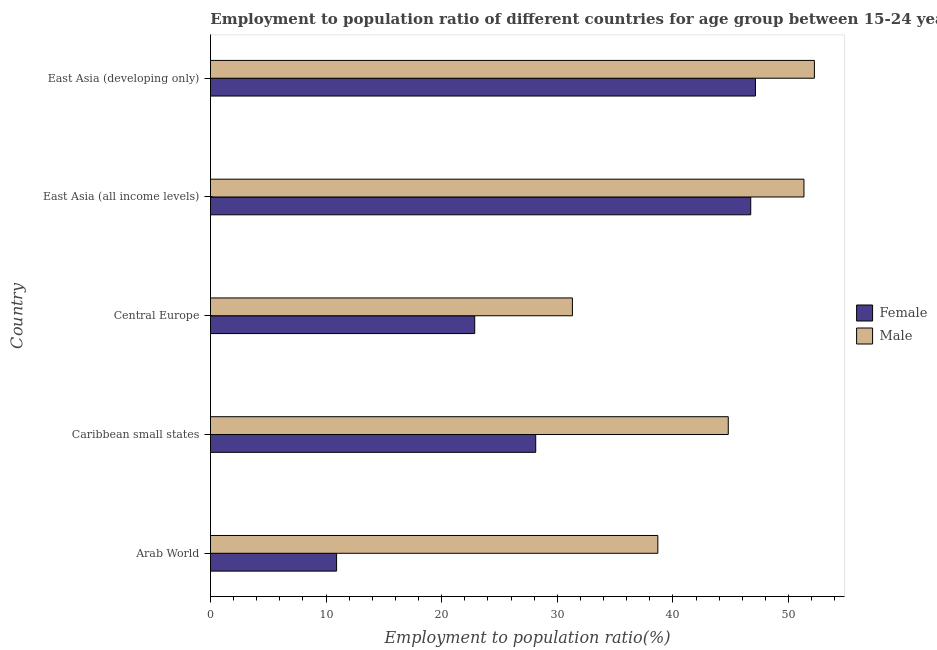How many different coloured bars are there?
Offer a terse response. 2. How many groups of bars are there?
Provide a short and direct response. 5. Are the number of bars on each tick of the Y-axis equal?
Give a very brief answer. Yes. How many bars are there on the 4th tick from the bottom?
Provide a short and direct response. 2. What is the label of the 2nd group of bars from the top?
Keep it short and to the point. East Asia (all income levels). In how many cases, is the number of bars for a given country not equal to the number of legend labels?
Keep it short and to the point. 0. What is the employment to population ratio(male) in Central Europe?
Ensure brevity in your answer.  31.31. Across all countries, what is the maximum employment to population ratio(male)?
Provide a short and direct response. 52.23. Across all countries, what is the minimum employment to population ratio(male)?
Offer a very short reply. 31.31. In which country was the employment to population ratio(female) maximum?
Offer a very short reply. East Asia (developing only). In which country was the employment to population ratio(female) minimum?
Offer a terse response. Arab World. What is the total employment to population ratio(female) in the graph?
Your answer should be compact. 155.76. What is the difference between the employment to population ratio(male) in Arab World and that in East Asia (developing only)?
Give a very brief answer. -13.54. What is the difference between the employment to population ratio(female) in East Asia (developing only) and the employment to population ratio(male) in Arab World?
Offer a very short reply. 8.44. What is the average employment to population ratio(male) per country?
Keep it short and to the point. 43.67. What is the difference between the employment to population ratio(male) and employment to population ratio(female) in Arab World?
Offer a terse response. 27.79. What is the ratio of the employment to population ratio(male) in Caribbean small states to that in Central Europe?
Provide a short and direct response. 1.43. Is the difference between the employment to population ratio(male) in Arab World and Caribbean small states greater than the difference between the employment to population ratio(female) in Arab World and Caribbean small states?
Keep it short and to the point. Yes. What is the difference between the highest and the second highest employment to population ratio(female)?
Your response must be concise. 0.41. What is the difference between the highest and the lowest employment to population ratio(female)?
Your response must be concise. 36.23. What does the 1st bar from the top in East Asia (all income levels) represents?
Your answer should be very brief. Male. Are all the bars in the graph horizontal?
Offer a very short reply. Yes. Does the graph contain any zero values?
Ensure brevity in your answer.  No. Does the graph contain grids?
Give a very brief answer. No. Where does the legend appear in the graph?
Make the answer very short. Center right. How many legend labels are there?
Provide a succinct answer. 2. How are the legend labels stacked?
Your answer should be very brief. Vertical. What is the title of the graph?
Ensure brevity in your answer.  Employment to population ratio of different countries for age group between 15-24 years. Does "Taxes on exports" appear as one of the legend labels in the graph?
Give a very brief answer. No. What is the label or title of the X-axis?
Your answer should be very brief. Employment to population ratio(%). What is the label or title of the Y-axis?
Ensure brevity in your answer.  Country. What is the Employment to population ratio(%) of Female in Arab World?
Make the answer very short. 10.91. What is the Employment to population ratio(%) of Male in Arab World?
Offer a very short reply. 38.69. What is the Employment to population ratio(%) in Female in Caribbean small states?
Keep it short and to the point. 28.13. What is the Employment to population ratio(%) of Male in Caribbean small states?
Your answer should be very brief. 44.79. What is the Employment to population ratio(%) in Female in Central Europe?
Ensure brevity in your answer.  22.86. What is the Employment to population ratio(%) of Male in Central Europe?
Ensure brevity in your answer.  31.31. What is the Employment to population ratio(%) of Female in East Asia (all income levels)?
Provide a short and direct response. 46.73. What is the Employment to population ratio(%) in Male in East Asia (all income levels)?
Your answer should be compact. 51.33. What is the Employment to population ratio(%) of Female in East Asia (developing only)?
Give a very brief answer. 47.14. What is the Employment to population ratio(%) in Male in East Asia (developing only)?
Ensure brevity in your answer.  52.23. Across all countries, what is the maximum Employment to population ratio(%) in Female?
Make the answer very short. 47.14. Across all countries, what is the maximum Employment to population ratio(%) of Male?
Your response must be concise. 52.23. Across all countries, what is the minimum Employment to population ratio(%) of Female?
Provide a succinct answer. 10.91. Across all countries, what is the minimum Employment to population ratio(%) in Male?
Offer a terse response. 31.31. What is the total Employment to population ratio(%) in Female in the graph?
Keep it short and to the point. 155.76. What is the total Employment to population ratio(%) of Male in the graph?
Offer a very short reply. 218.35. What is the difference between the Employment to population ratio(%) of Female in Arab World and that in Caribbean small states?
Provide a short and direct response. -17.22. What is the difference between the Employment to population ratio(%) of Male in Arab World and that in Caribbean small states?
Ensure brevity in your answer.  -6.09. What is the difference between the Employment to population ratio(%) in Female in Arab World and that in Central Europe?
Ensure brevity in your answer.  -11.95. What is the difference between the Employment to population ratio(%) of Male in Arab World and that in Central Europe?
Provide a short and direct response. 7.39. What is the difference between the Employment to population ratio(%) in Female in Arab World and that in East Asia (all income levels)?
Ensure brevity in your answer.  -35.82. What is the difference between the Employment to population ratio(%) in Male in Arab World and that in East Asia (all income levels)?
Give a very brief answer. -12.64. What is the difference between the Employment to population ratio(%) of Female in Arab World and that in East Asia (developing only)?
Provide a short and direct response. -36.23. What is the difference between the Employment to population ratio(%) of Male in Arab World and that in East Asia (developing only)?
Offer a terse response. -13.54. What is the difference between the Employment to population ratio(%) of Female in Caribbean small states and that in Central Europe?
Your response must be concise. 5.28. What is the difference between the Employment to population ratio(%) in Male in Caribbean small states and that in Central Europe?
Offer a very short reply. 13.48. What is the difference between the Employment to population ratio(%) of Female in Caribbean small states and that in East Asia (all income levels)?
Provide a succinct answer. -18.6. What is the difference between the Employment to population ratio(%) in Male in Caribbean small states and that in East Asia (all income levels)?
Ensure brevity in your answer.  -6.55. What is the difference between the Employment to population ratio(%) in Female in Caribbean small states and that in East Asia (developing only)?
Give a very brief answer. -19. What is the difference between the Employment to population ratio(%) in Male in Caribbean small states and that in East Asia (developing only)?
Provide a short and direct response. -7.45. What is the difference between the Employment to population ratio(%) in Female in Central Europe and that in East Asia (all income levels)?
Offer a terse response. -23.87. What is the difference between the Employment to population ratio(%) in Male in Central Europe and that in East Asia (all income levels)?
Your answer should be very brief. -20.03. What is the difference between the Employment to population ratio(%) of Female in Central Europe and that in East Asia (developing only)?
Ensure brevity in your answer.  -24.28. What is the difference between the Employment to population ratio(%) of Male in Central Europe and that in East Asia (developing only)?
Offer a very short reply. -20.93. What is the difference between the Employment to population ratio(%) of Female in East Asia (all income levels) and that in East Asia (developing only)?
Your answer should be compact. -0.41. What is the difference between the Employment to population ratio(%) of Male in East Asia (all income levels) and that in East Asia (developing only)?
Keep it short and to the point. -0.9. What is the difference between the Employment to population ratio(%) in Female in Arab World and the Employment to population ratio(%) in Male in Caribbean small states?
Offer a terse response. -33.88. What is the difference between the Employment to population ratio(%) of Female in Arab World and the Employment to population ratio(%) of Male in Central Europe?
Keep it short and to the point. -20.4. What is the difference between the Employment to population ratio(%) in Female in Arab World and the Employment to population ratio(%) in Male in East Asia (all income levels)?
Ensure brevity in your answer.  -40.42. What is the difference between the Employment to population ratio(%) of Female in Arab World and the Employment to population ratio(%) of Male in East Asia (developing only)?
Keep it short and to the point. -41.33. What is the difference between the Employment to population ratio(%) of Female in Caribbean small states and the Employment to population ratio(%) of Male in Central Europe?
Provide a succinct answer. -3.17. What is the difference between the Employment to population ratio(%) in Female in Caribbean small states and the Employment to population ratio(%) in Male in East Asia (all income levels)?
Give a very brief answer. -23.2. What is the difference between the Employment to population ratio(%) in Female in Caribbean small states and the Employment to population ratio(%) in Male in East Asia (developing only)?
Your response must be concise. -24.1. What is the difference between the Employment to population ratio(%) in Female in Central Europe and the Employment to population ratio(%) in Male in East Asia (all income levels)?
Ensure brevity in your answer.  -28.48. What is the difference between the Employment to population ratio(%) in Female in Central Europe and the Employment to population ratio(%) in Male in East Asia (developing only)?
Ensure brevity in your answer.  -29.38. What is the difference between the Employment to population ratio(%) in Female in East Asia (all income levels) and the Employment to population ratio(%) in Male in East Asia (developing only)?
Your answer should be compact. -5.51. What is the average Employment to population ratio(%) in Female per country?
Your answer should be very brief. 31.15. What is the average Employment to population ratio(%) of Male per country?
Give a very brief answer. 43.67. What is the difference between the Employment to population ratio(%) in Female and Employment to population ratio(%) in Male in Arab World?
Keep it short and to the point. -27.79. What is the difference between the Employment to population ratio(%) in Female and Employment to population ratio(%) in Male in Caribbean small states?
Provide a short and direct response. -16.65. What is the difference between the Employment to population ratio(%) of Female and Employment to population ratio(%) of Male in Central Europe?
Keep it short and to the point. -8.45. What is the difference between the Employment to population ratio(%) in Female and Employment to population ratio(%) in Male in East Asia (all income levels)?
Give a very brief answer. -4.6. What is the difference between the Employment to population ratio(%) in Female and Employment to population ratio(%) in Male in East Asia (developing only)?
Your answer should be very brief. -5.1. What is the ratio of the Employment to population ratio(%) of Female in Arab World to that in Caribbean small states?
Provide a succinct answer. 0.39. What is the ratio of the Employment to population ratio(%) of Male in Arab World to that in Caribbean small states?
Provide a succinct answer. 0.86. What is the ratio of the Employment to population ratio(%) in Female in Arab World to that in Central Europe?
Ensure brevity in your answer.  0.48. What is the ratio of the Employment to population ratio(%) in Male in Arab World to that in Central Europe?
Your response must be concise. 1.24. What is the ratio of the Employment to population ratio(%) in Female in Arab World to that in East Asia (all income levels)?
Offer a terse response. 0.23. What is the ratio of the Employment to population ratio(%) of Male in Arab World to that in East Asia (all income levels)?
Keep it short and to the point. 0.75. What is the ratio of the Employment to population ratio(%) of Female in Arab World to that in East Asia (developing only)?
Ensure brevity in your answer.  0.23. What is the ratio of the Employment to population ratio(%) of Male in Arab World to that in East Asia (developing only)?
Provide a succinct answer. 0.74. What is the ratio of the Employment to population ratio(%) of Female in Caribbean small states to that in Central Europe?
Offer a terse response. 1.23. What is the ratio of the Employment to population ratio(%) in Male in Caribbean small states to that in Central Europe?
Provide a short and direct response. 1.43. What is the ratio of the Employment to population ratio(%) of Female in Caribbean small states to that in East Asia (all income levels)?
Keep it short and to the point. 0.6. What is the ratio of the Employment to population ratio(%) in Male in Caribbean small states to that in East Asia (all income levels)?
Provide a succinct answer. 0.87. What is the ratio of the Employment to population ratio(%) in Female in Caribbean small states to that in East Asia (developing only)?
Your answer should be compact. 0.6. What is the ratio of the Employment to population ratio(%) of Male in Caribbean small states to that in East Asia (developing only)?
Make the answer very short. 0.86. What is the ratio of the Employment to population ratio(%) in Female in Central Europe to that in East Asia (all income levels)?
Keep it short and to the point. 0.49. What is the ratio of the Employment to population ratio(%) in Male in Central Europe to that in East Asia (all income levels)?
Keep it short and to the point. 0.61. What is the ratio of the Employment to population ratio(%) of Female in Central Europe to that in East Asia (developing only)?
Give a very brief answer. 0.48. What is the ratio of the Employment to population ratio(%) of Male in Central Europe to that in East Asia (developing only)?
Your response must be concise. 0.6. What is the ratio of the Employment to population ratio(%) of Female in East Asia (all income levels) to that in East Asia (developing only)?
Provide a short and direct response. 0.99. What is the ratio of the Employment to population ratio(%) of Male in East Asia (all income levels) to that in East Asia (developing only)?
Give a very brief answer. 0.98. What is the difference between the highest and the second highest Employment to population ratio(%) in Female?
Give a very brief answer. 0.41. What is the difference between the highest and the second highest Employment to population ratio(%) of Male?
Your response must be concise. 0.9. What is the difference between the highest and the lowest Employment to population ratio(%) in Female?
Your answer should be compact. 36.23. What is the difference between the highest and the lowest Employment to population ratio(%) in Male?
Offer a very short reply. 20.93. 